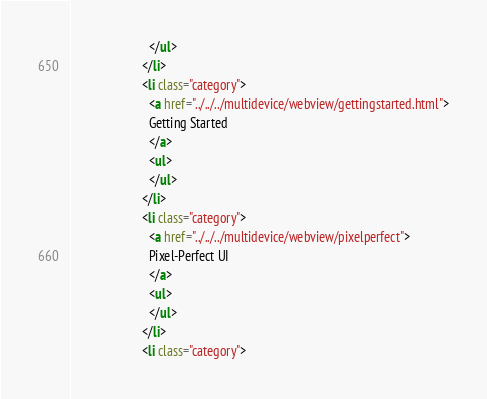Convert code to text. <code><loc_0><loc_0><loc_500><loc_500><_HTML_>                        </ul>
                      </li>
                      <li class="category">
                        <a href="../../../multidevice/webview/gettingstarted.html">
                        Getting Started
                        </a>
                        <ul>
                        </ul>
                      </li>
                      <li class="category">
                        <a href="../../../multidevice/webview/pixelperfect">
                        Pixel-Perfect UI
                        </a>
                        <ul>
                        </ul>
                      </li>
                      <li class="category"></code> 